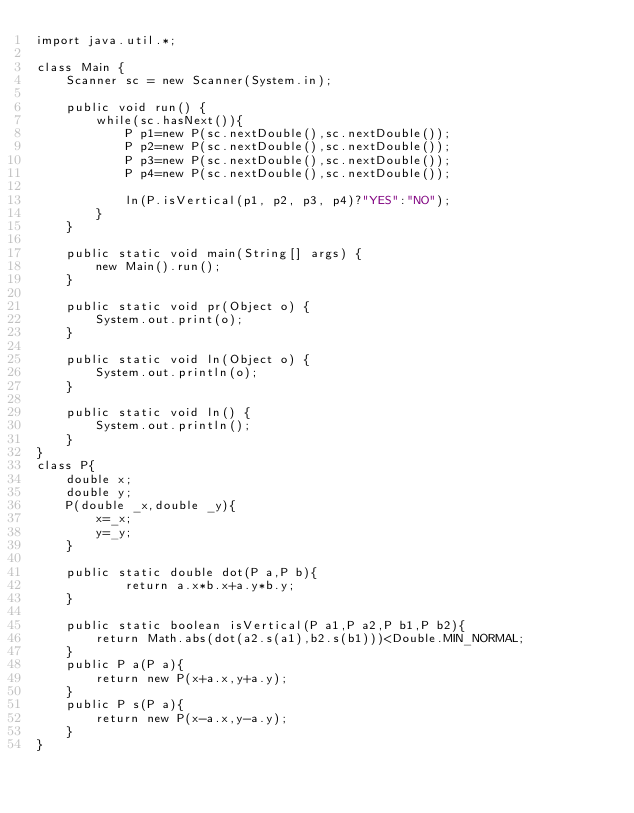<code> <loc_0><loc_0><loc_500><loc_500><_Java_>import java.util.*;

class Main {
	Scanner sc = new Scanner(System.in);

	public void run() {
		while(sc.hasNext()){
			P p1=new P(sc.nextDouble(),sc.nextDouble());
			P p2=new P(sc.nextDouble(),sc.nextDouble());
			P p3=new P(sc.nextDouble(),sc.nextDouble());
			P p4=new P(sc.nextDouble(),sc.nextDouble());

			ln(P.isVertical(p1, p2, p3, p4)?"YES":"NO");
		}
	}

	public static void main(String[] args) {
		new Main().run();
	}

	public static void pr(Object o) {
		System.out.print(o);
	}

	public static void ln(Object o) {
		System.out.println(o);
	}

	public static void ln() {
		System.out.println();
	}
}
class P{
	double x;
	double y;
	P(double _x,double _y){
		x=_x;
		y=_y;
	}

	public static double dot(P a,P b){
			return a.x*b.x+a.y*b.y;
	}

	public static boolean isVertical(P a1,P a2,P b1,P b2){
		return Math.abs(dot(a2.s(a1),b2.s(b1)))<Double.MIN_NORMAL;
	}
	public P a(P a){
		return new P(x+a.x,y+a.y);
	}
	public P s(P a){
		return new P(x-a.x,y-a.y);
	}
}</code> 